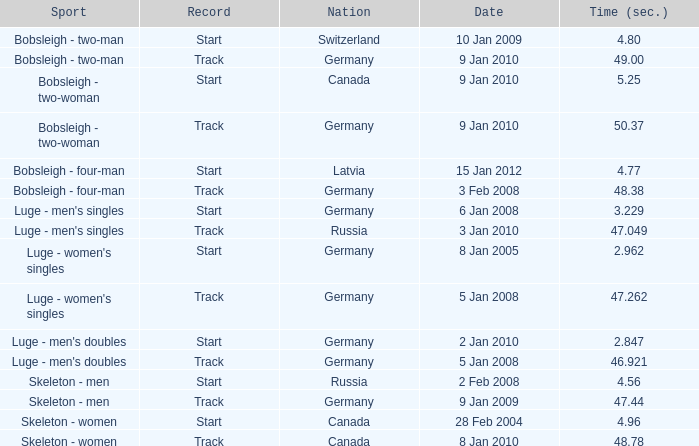Which sport has a time over 49? Bobsleigh - two-woman. 